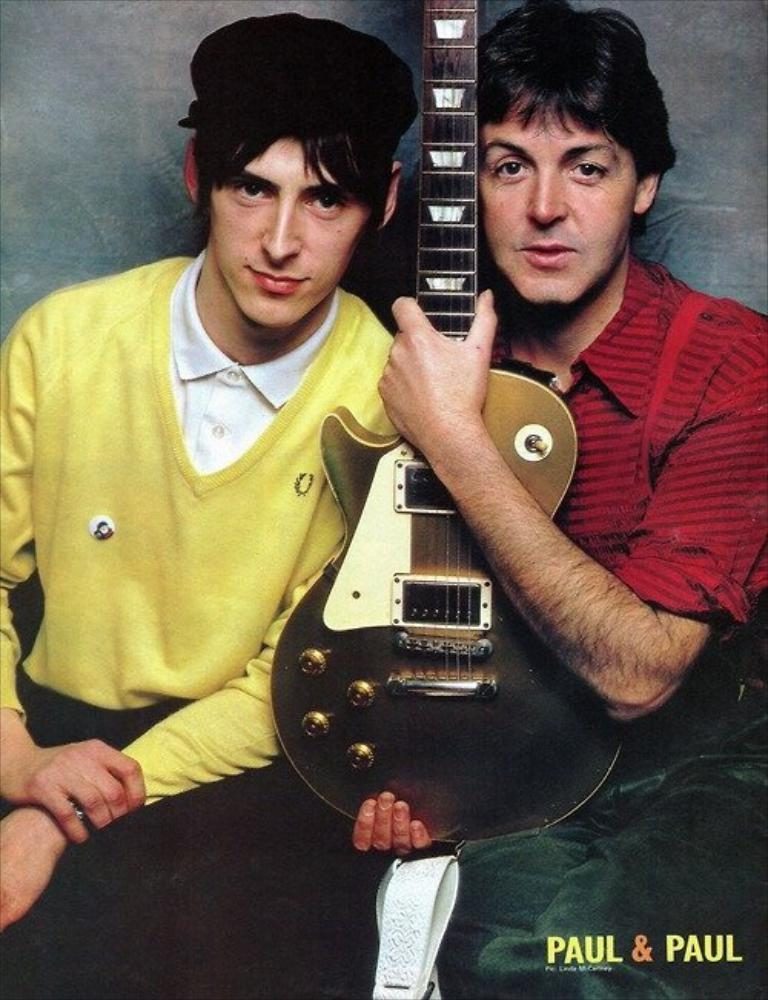How many people are in the image? There are two persons in the image. What is one of the persons doing in the image? One of the persons is holding a guitar with his hands. What country is the guitar from in the image? The image does not provide information about the origin of the guitar, so it cannot be determined from the image. How many feet can be seen in the image? The image does not show any feet, so it cannot be determined from the image. 